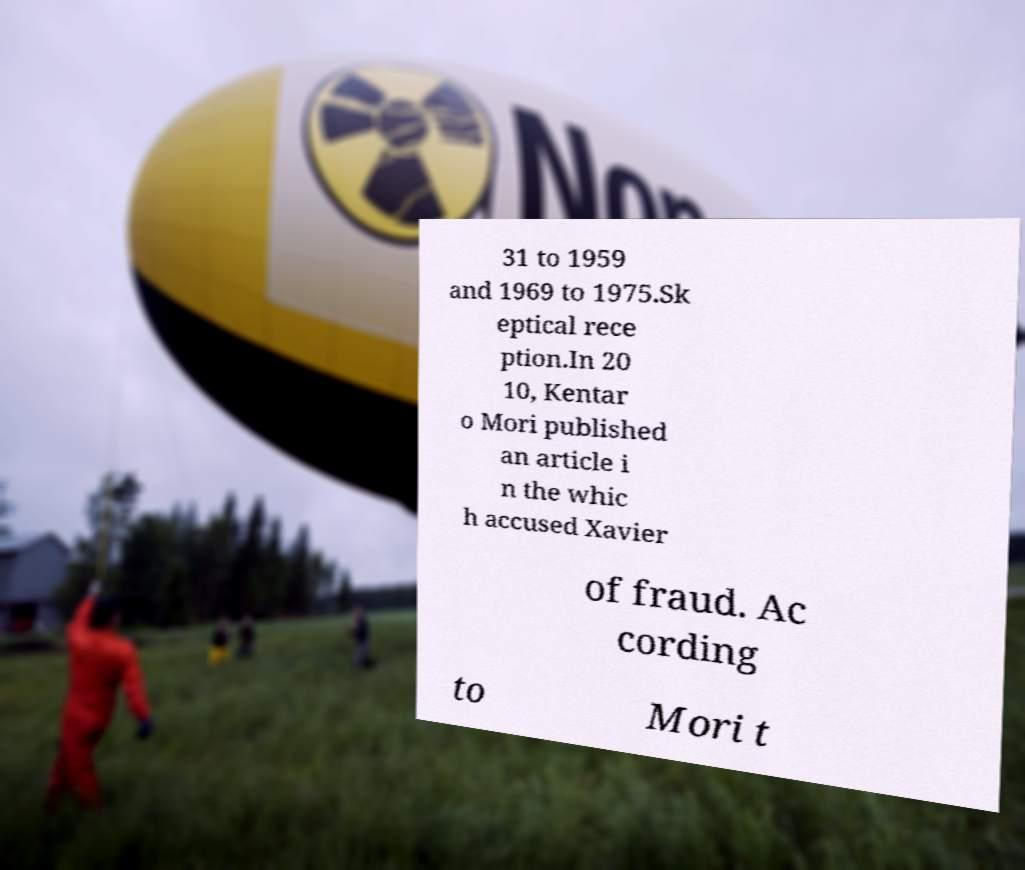Can you accurately transcribe the text from the provided image for me? 31 to 1959 and 1969 to 1975.Sk eptical rece ption.In 20 10, Kentar o Mori published an article i n the whic h accused Xavier of fraud. Ac cording to Mori t 